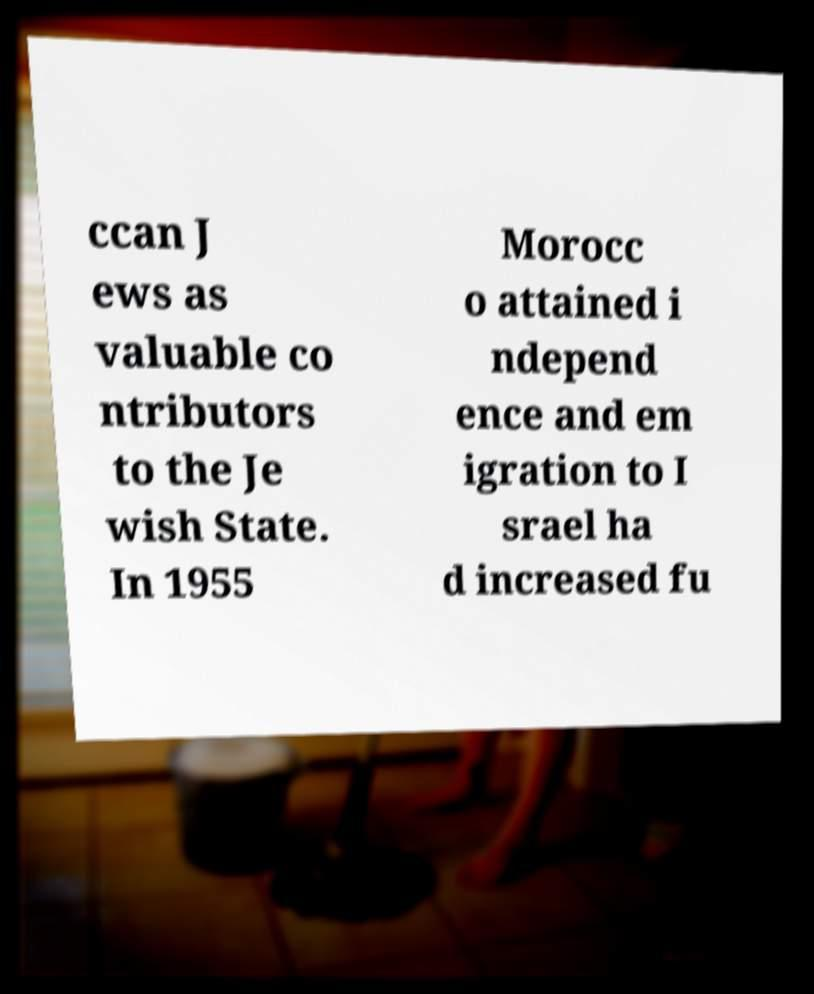Could you assist in decoding the text presented in this image and type it out clearly? ccan J ews as valuable co ntributors to the Je wish State. In 1955 Morocc o attained i ndepend ence and em igration to I srael ha d increased fu 